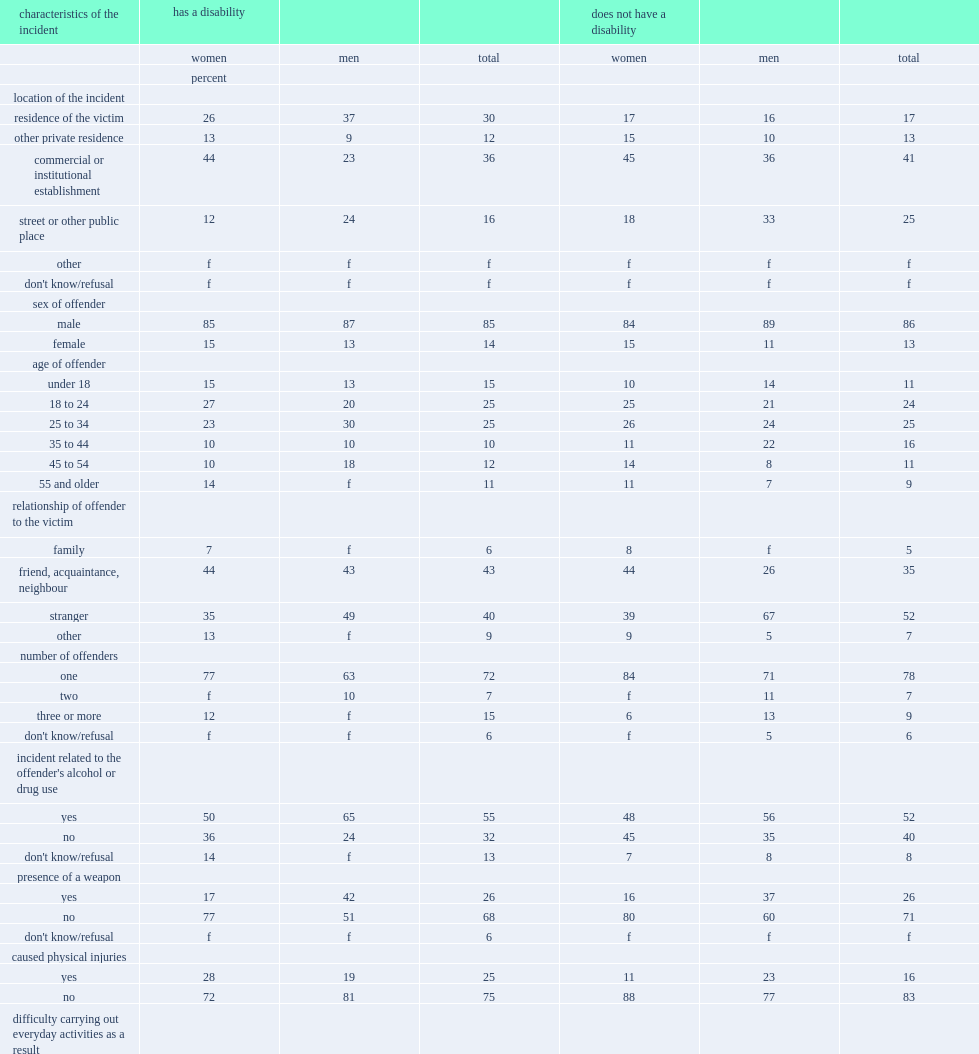How many percent of women with a disability who were victimized most often reported that the perpetrator was a friend, acquaintance, or neighbour? 44.0. How many percent of women with a disability who were victimized most often reported that the perpetrator was a stranger? 35.0. Which characteristics of the incident were men with a disability more likely to be victimized by a friend, acquaintance, or neighbour? Has a disability. What was the proportion of men victimized by a stranger among those with a disability? 49.0. What was the proportion of men victimized by a stranger among those with a disability? 67.0. 